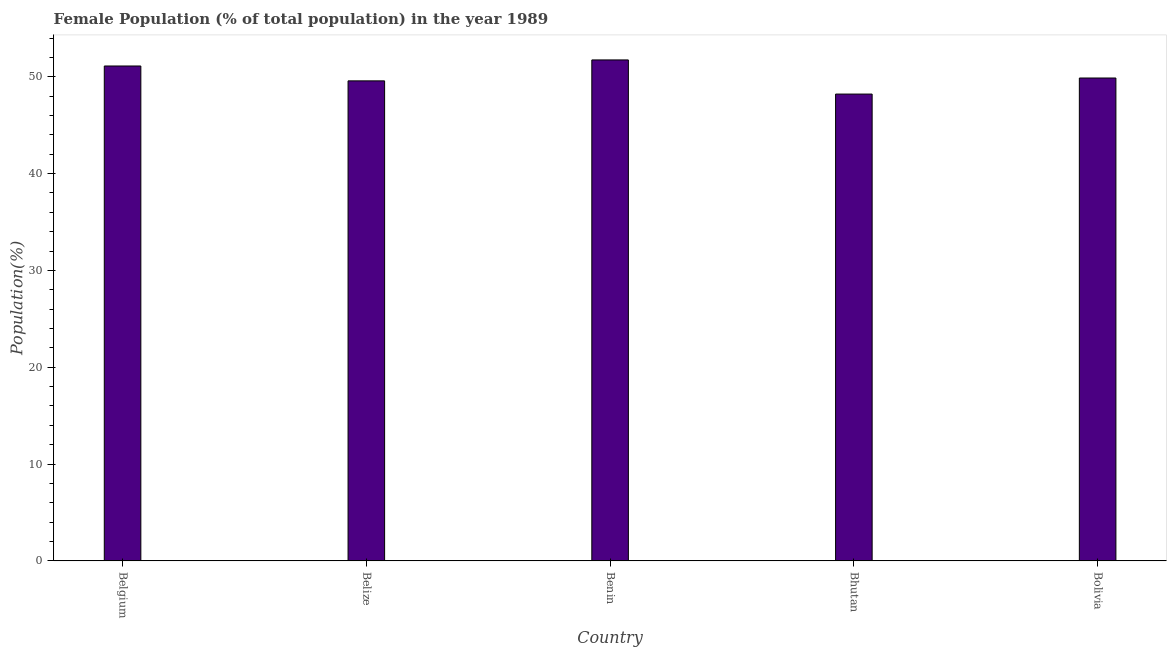Does the graph contain any zero values?
Keep it short and to the point. No. What is the title of the graph?
Your response must be concise. Female Population (% of total population) in the year 1989. What is the label or title of the Y-axis?
Ensure brevity in your answer.  Population(%). What is the female population in Benin?
Offer a very short reply. 51.75. Across all countries, what is the maximum female population?
Offer a terse response. 51.75. Across all countries, what is the minimum female population?
Provide a succinct answer. 48.22. In which country was the female population maximum?
Your answer should be very brief. Benin. In which country was the female population minimum?
Your response must be concise. Bhutan. What is the sum of the female population?
Your answer should be compact. 250.54. What is the difference between the female population in Belgium and Belize?
Your answer should be compact. 1.54. What is the average female population per country?
Make the answer very short. 50.11. What is the median female population?
Your response must be concise. 49.88. What is the ratio of the female population in Belize to that in Bolivia?
Provide a succinct answer. 0.99. What is the difference between the highest and the second highest female population?
Your answer should be very brief. 0.63. What is the difference between the highest and the lowest female population?
Make the answer very short. 3.53. Are all the bars in the graph horizontal?
Provide a succinct answer. No. How many countries are there in the graph?
Ensure brevity in your answer.  5. What is the difference between two consecutive major ticks on the Y-axis?
Your answer should be compact. 10. What is the Population(%) of Belgium?
Offer a terse response. 51.12. What is the Population(%) in Belize?
Offer a very short reply. 49.58. What is the Population(%) of Benin?
Provide a succinct answer. 51.75. What is the Population(%) in Bhutan?
Give a very brief answer. 48.22. What is the Population(%) of Bolivia?
Provide a succinct answer. 49.88. What is the difference between the Population(%) in Belgium and Belize?
Provide a short and direct response. 1.54. What is the difference between the Population(%) in Belgium and Benin?
Ensure brevity in your answer.  -0.63. What is the difference between the Population(%) in Belgium and Bhutan?
Provide a short and direct response. 2.9. What is the difference between the Population(%) in Belgium and Bolivia?
Keep it short and to the point. 1.24. What is the difference between the Population(%) in Belize and Benin?
Offer a terse response. -2.16. What is the difference between the Population(%) in Belize and Bhutan?
Your answer should be very brief. 1.36. What is the difference between the Population(%) in Belize and Bolivia?
Give a very brief answer. -0.3. What is the difference between the Population(%) in Benin and Bhutan?
Make the answer very short. 3.53. What is the difference between the Population(%) in Benin and Bolivia?
Provide a short and direct response. 1.87. What is the difference between the Population(%) in Bhutan and Bolivia?
Offer a terse response. -1.66. What is the ratio of the Population(%) in Belgium to that in Belize?
Give a very brief answer. 1.03. What is the ratio of the Population(%) in Belgium to that in Bhutan?
Ensure brevity in your answer.  1.06. What is the ratio of the Population(%) in Belize to that in Benin?
Your response must be concise. 0.96. What is the ratio of the Population(%) in Belize to that in Bhutan?
Offer a very short reply. 1.03. What is the ratio of the Population(%) in Belize to that in Bolivia?
Give a very brief answer. 0.99. What is the ratio of the Population(%) in Benin to that in Bhutan?
Offer a terse response. 1.07. 